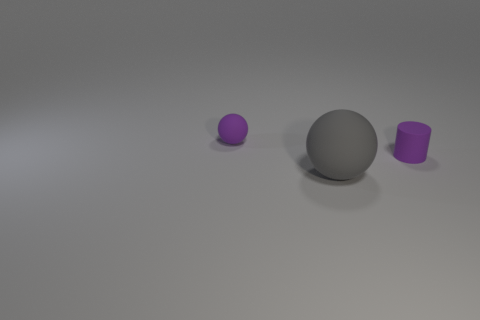Add 2 green blocks. How many objects exist? 5 Subtract all spheres. How many objects are left? 1 Subtract all green balls. Subtract all big rubber objects. How many objects are left? 2 Add 2 large rubber things. How many large rubber things are left? 3 Add 1 large gray matte balls. How many large gray matte balls exist? 2 Subtract 0 green cubes. How many objects are left? 3 